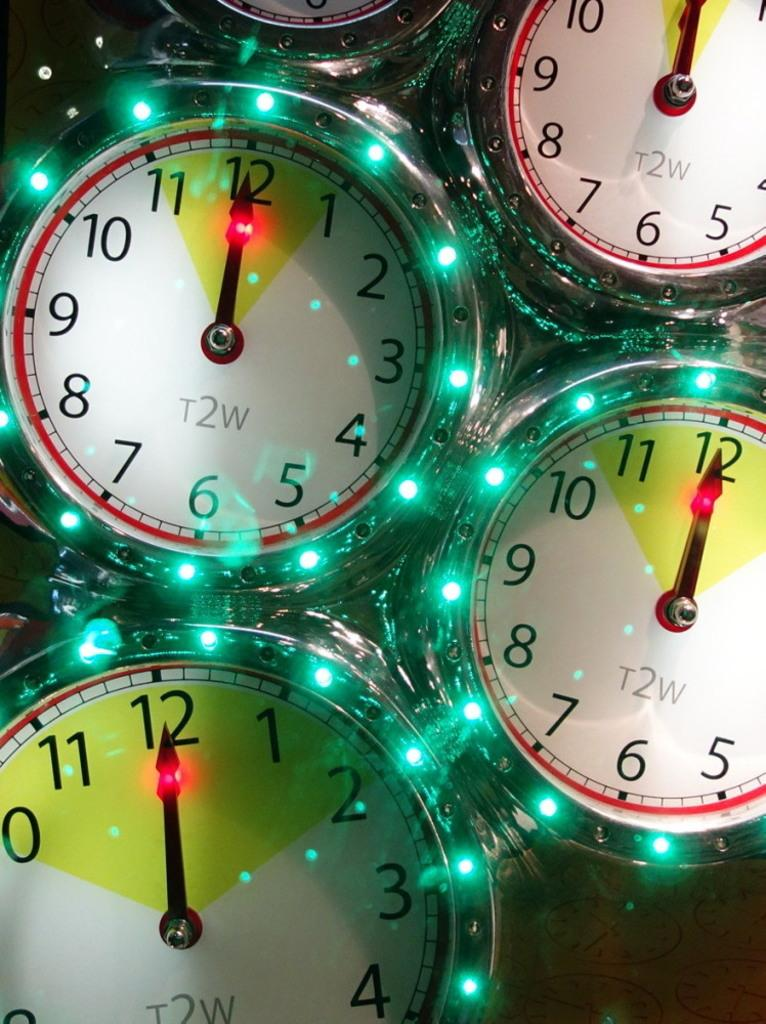<image>
Give a short and clear explanation of the subsequent image. Four clocks are displayed with the time of 12:00 and t2w on the face. 